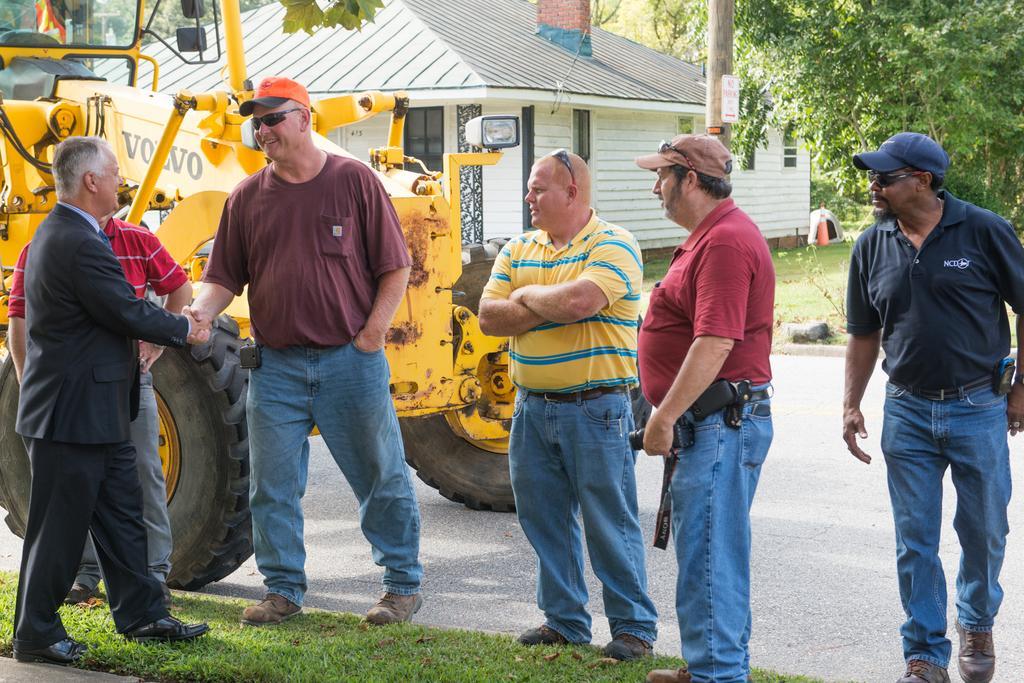Can you describe this image briefly? There are two men shaking hands on the left side of the image, there is a person behind them and there are men on the right side, there is grassland at the bottom side. There is a vehicle, house, traffic cone and trees in the background area. 